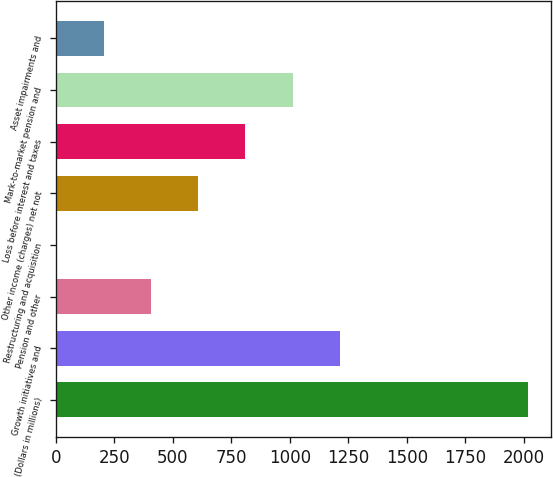<chart> <loc_0><loc_0><loc_500><loc_500><bar_chart><fcel>(Dollars in millions)<fcel>Growth initiatives and<fcel>Pension and other<fcel>Restructuring and acquisition<fcel>Other income (charges) net not<fcel>Loss before interest and taxes<fcel>Mark-to-market pension and<fcel>Asset impairments and<nl><fcel>2018<fcel>1213.2<fcel>408.4<fcel>6<fcel>609.6<fcel>810.8<fcel>1012<fcel>207.2<nl></chart> 